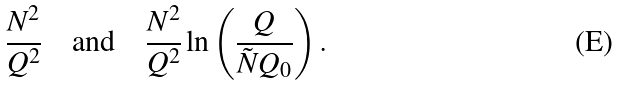Convert formula to latex. <formula><loc_0><loc_0><loc_500><loc_500>\frac { N ^ { 2 } } { Q ^ { 2 } } \quad \text {and} \quad \frac { N ^ { 2 } } { Q ^ { 2 } } \ln \left ( \frac { Q } { \tilde { N } Q _ { 0 } } \right ) .</formula> 